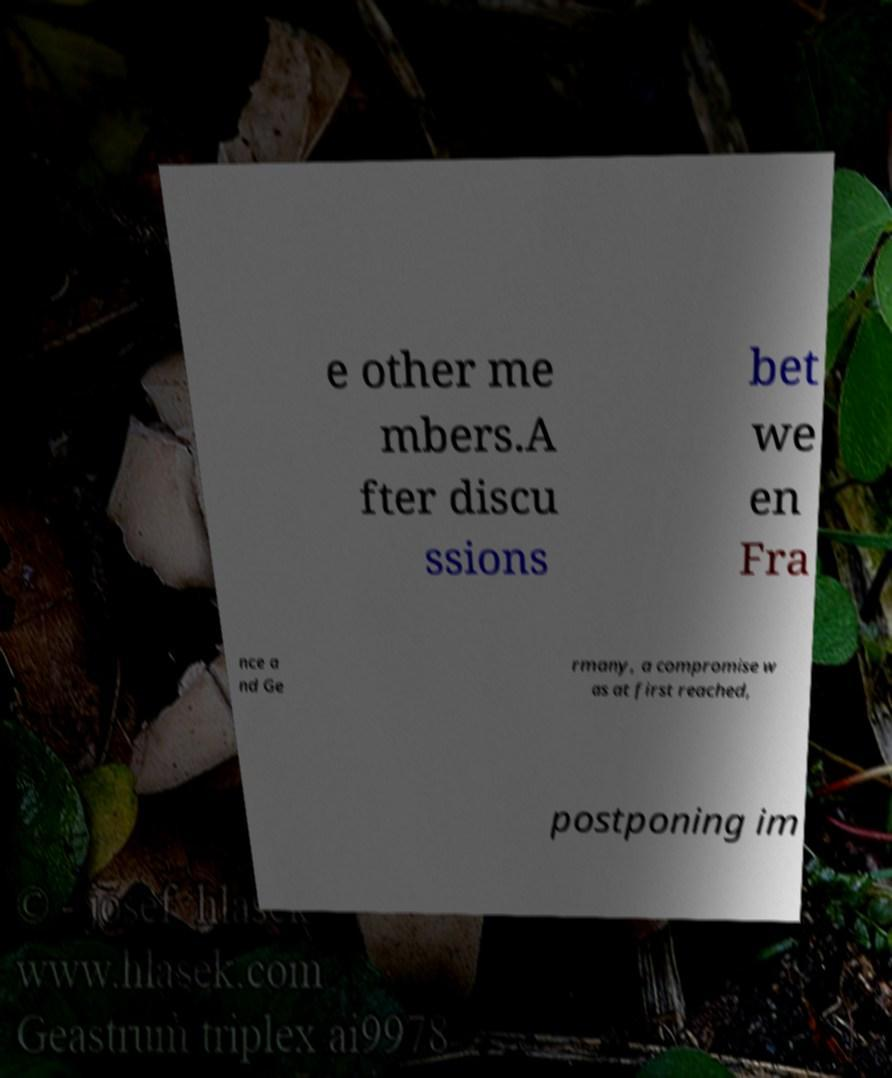Can you accurately transcribe the text from the provided image for me? e other me mbers.A fter discu ssions bet we en Fra nce a nd Ge rmany, a compromise w as at first reached, postponing im 